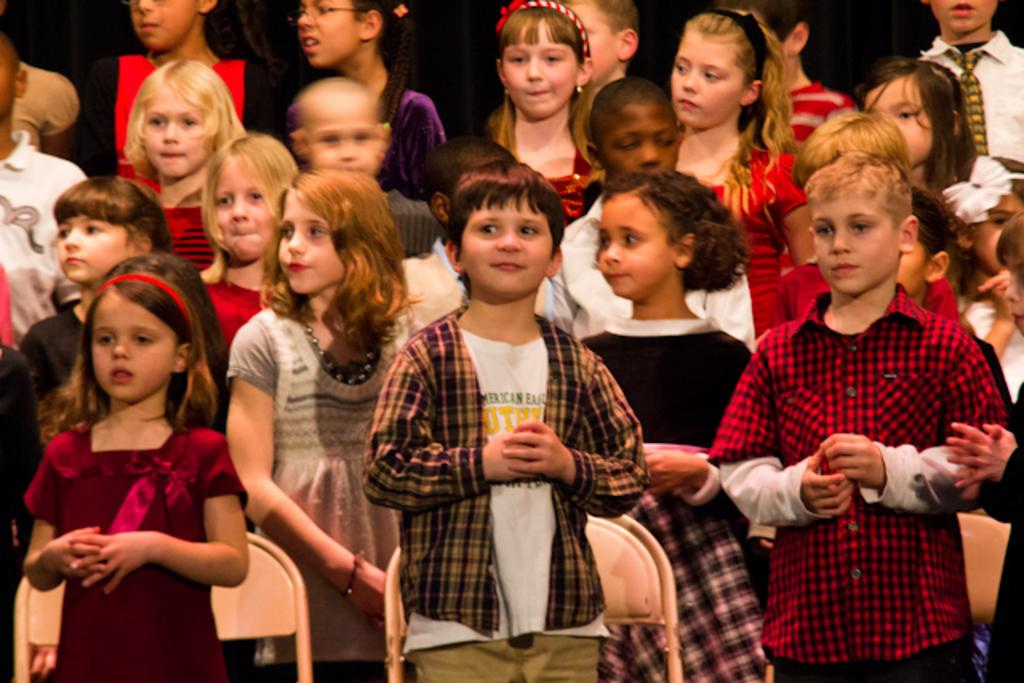What can be seen in the image? There are children standing in the image. What else is present in the image? There are chairs in the image. What type of rod is being used by the children in the image? There is no rod present in the image; the children are simply standing. 